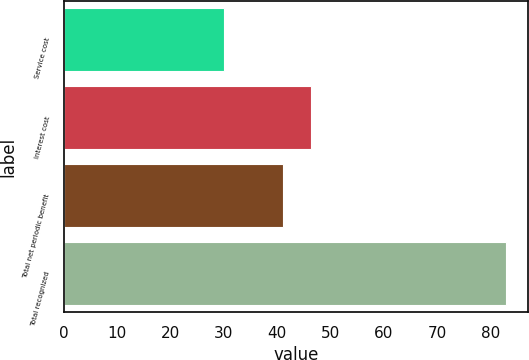Convert chart to OTSL. <chart><loc_0><loc_0><loc_500><loc_500><bar_chart><fcel>Service cost<fcel>Interest cost<fcel>Total net periodic benefit<fcel>Total recognized<nl><fcel>30<fcel>46.3<fcel>41<fcel>83<nl></chart> 